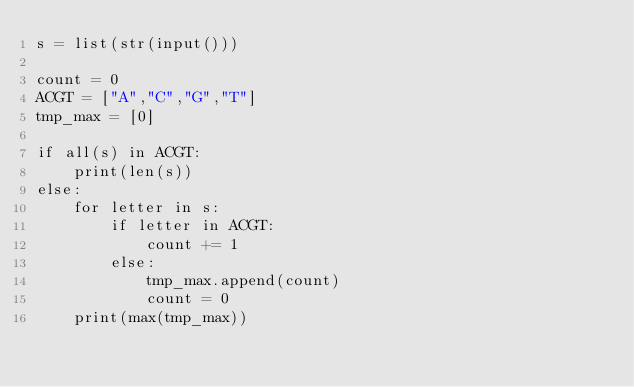Convert code to text. <code><loc_0><loc_0><loc_500><loc_500><_Python_>s = list(str(input()))

count = 0
ACGT = ["A","C","G","T"]
tmp_max = [0]

if all(s) in ACGT:
	print(len(s))
else:
	for letter in s:
		if letter in ACGT:
			count += 1
		else:
			tmp_max.append(count)
			count = 0
	print(max(tmp_max))</code> 